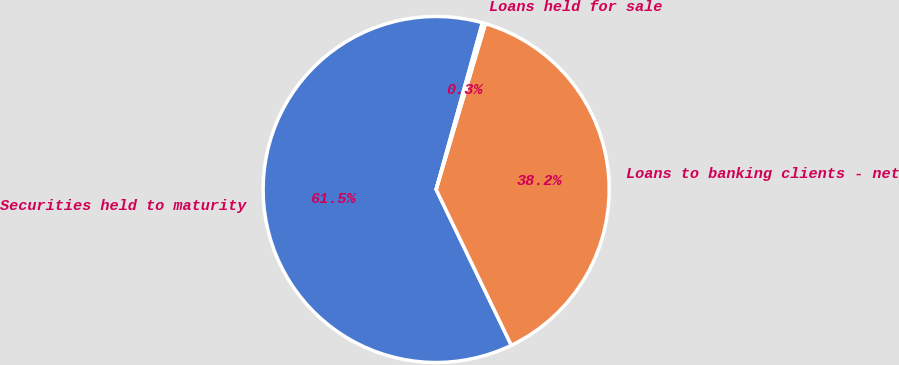Convert chart. <chart><loc_0><loc_0><loc_500><loc_500><pie_chart><fcel>Securities held to maturity<fcel>Loans to banking clients - net<fcel>Loans held for sale<nl><fcel>61.46%<fcel>38.25%<fcel>0.29%<nl></chart> 